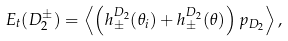Convert formula to latex. <formula><loc_0><loc_0><loc_500><loc_500>E _ { t } ( D _ { 2 } ^ { \pm } ) = \left < \left ( h _ { \pm } ^ { D _ { 2 } } ( \theta _ { i } ) + h _ { \pm } ^ { D _ { 2 } } ( \theta ) \right ) p _ { D _ { 2 } } \right > ,</formula> 